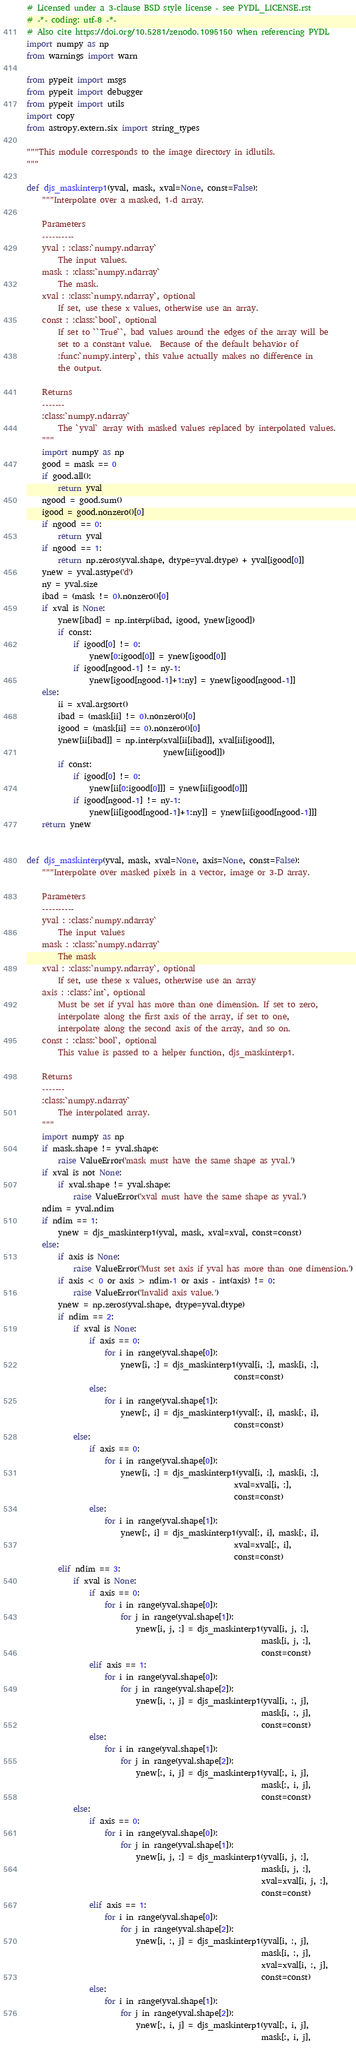<code> <loc_0><loc_0><loc_500><loc_500><_Python_># Licensed under a 3-clause BSD style license - see PYDL_LICENSE.rst
# -*- coding: utf-8 -*-
# Also cite https://doi.org/10.5281/zenodo.1095150 when referencing PYDL
import numpy as np
from warnings import warn

from pypeit import msgs
from pypeit import debugger
from pypeit import utils
import copy
from astropy.extern.six import string_types

"""This module corresponds to the image directory in idlutils.
"""

def djs_maskinterp1(yval, mask, xval=None, const=False):
    """Interpolate over a masked, 1-d array.

    Parameters
    ----------
    yval : :class:`numpy.ndarray`
        The input values.
    mask : :class:`numpy.ndarray`
        The mask.
    xval : :class:`numpy.ndarray`, optional
        If set, use these x values, otherwise use an array.
    const : :class:`bool`, optional
        If set to ``True``, bad values around the edges of the array will be
        set to a constant value.  Because of the default behavior of
        :func:`numpy.interp`, this value actually makes no difference in
        the output.

    Returns
    -------
    :class:`numpy.ndarray`
        The `yval` array with masked values replaced by interpolated values.
    """
    import numpy as np
    good = mask == 0
    if good.all():
        return yval
    ngood = good.sum()
    igood = good.nonzero()[0]
    if ngood == 0:
        return yval
    if ngood == 1:
        return np.zeros(yval.shape, dtype=yval.dtype) + yval[igood[0]]
    ynew = yval.astype('d')
    ny = yval.size
    ibad = (mask != 0).nonzero()[0]
    if xval is None:
        ynew[ibad] = np.interp(ibad, igood, ynew[igood])
        if const:
            if igood[0] != 0:
                ynew[0:igood[0]] = ynew[igood[0]]
            if igood[ngood-1] != ny-1:
                ynew[igood[ngood-1]+1:ny] = ynew[igood[ngood-1]]
    else:
        ii = xval.argsort()
        ibad = (mask[ii] != 0).nonzero()[0]
        igood = (mask[ii] == 0).nonzero()[0]
        ynew[ii[ibad]] = np.interp(xval[ii[ibad]], xval[ii[igood]],
                                   ynew[ii[igood]])
        if const:
            if igood[0] != 0:
                ynew[ii[0:igood[0]]] = ynew[ii[igood[0]]]
            if igood[ngood-1] != ny-1:
                ynew[ii[igood[ngood-1]+1:ny]] = ynew[ii[igood[ngood-1]]]
    return ynew


def djs_maskinterp(yval, mask, xval=None, axis=None, const=False):
    """Interpolate over masked pixels in a vector, image or 3-D array.

    Parameters
    ----------
    yval : :class:`numpy.ndarray`
        The input values
    mask : :class:`numpy.ndarray`
        The mask
    xval : :class:`numpy.ndarray`, optional
        If set, use these x values, otherwise use an array
    axis : :class:`int`, optional
        Must be set if yval has more than one dimension. If set to zero,
        interpolate along the first axis of the array, if set to one,
        interpolate along the second axis of the array, and so on.
    const : :class:`bool`, optional
        This value is passed to a helper function, djs_maskinterp1.

    Returns
    -------
    :class:`numpy.ndarray`
        The interpolated array.
    """
    import numpy as np
    if mask.shape != yval.shape:
        raise ValueError('mask must have the same shape as yval.')
    if xval is not None:
        if xval.shape != yval.shape:
            raise ValueError('xval must have the same shape as yval.')
    ndim = yval.ndim
    if ndim == 1:
        ynew = djs_maskinterp1(yval, mask, xval=xval, const=const)
    else:
        if axis is None:
            raise ValueError('Must set axis if yval has more than one dimension.')
        if axis < 0 or axis > ndim-1 or axis - int(axis) != 0:
            raise ValueError('Invalid axis value.')
        ynew = np.zeros(yval.shape, dtype=yval.dtype)
        if ndim == 2:
            if xval is None:
                if axis == 0:
                    for i in range(yval.shape[0]):
                        ynew[i, :] = djs_maskinterp1(yval[i, :], mask[i, :],
                                                     const=const)
                else:
                    for i in range(yval.shape[1]):
                        ynew[:, i] = djs_maskinterp1(yval[:, i], mask[:, i],
                                                     const=const)
            else:
                if axis == 0:
                    for i in range(yval.shape[0]):
                        ynew[i, :] = djs_maskinterp1(yval[i, :], mask[i, :],
                                                     xval=xval[i, :],
                                                     const=const)
                else:
                    for i in range(yval.shape[1]):
                        ynew[:, i] = djs_maskinterp1(yval[:, i], mask[:, i],
                                                     xval=xval[:, i],
                                                     const=const)
        elif ndim == 3:
            if xval is None:
                if axis == 0:
                    for i in range(yval.shape[0]):
                        for j in range(yval.shape[1]):
                            ynew[i, j, :] = djs_maskinterp1(yval[i, j, :],
                                                            mask[i, j, :],
                                                            const=const)
                elif axis == 1:
                    for i in range(yval.shape[0]):
                        for j in range(yval.shape[2]):
                            ynew[i, :, j] = djs_maskinterp1(yval[i, :, j],
                                                            mask[i, :, j],
                                                            const=const)
                else:
                    for i in range(yval.shape[1]):
                        for j in range(yval.shape[2]):
                            ynew[:, i, j] = djs_maskinterp1(yval[:, i, j],
                                                            mask[:, i, j],
                                                            const=const)
            else:
                if axis == 0:
                    for i in range(yval.shape[0]):
                        for j in range(yval.shape[1]):
                            ynew[i, j, :] = djs_maskinterp1(yval[i, j, :],
                                                            mask[i, j, :],
                                                            xval=xval[i, j, :],
                                                            const=const)
                elif axis == 1:
                    for i in range(yval.shape[0]):
                        for j in range(yval.shape[2]):
                            ynew[i, :, j] = djs_maskinterp1(yval[i, :, j],
                                                            mask[i, :, j],
                                                            xval=xval[i, :, j],
                                                            const=const)
                else:
                    for i in range(yval.shape[1]):
                        for j in range(yval.shape[2]):
                            ynew[:, i, j] = djs_maskinterp1(yval[:, i, j],
                                                            mask[:, i, j],</code> 